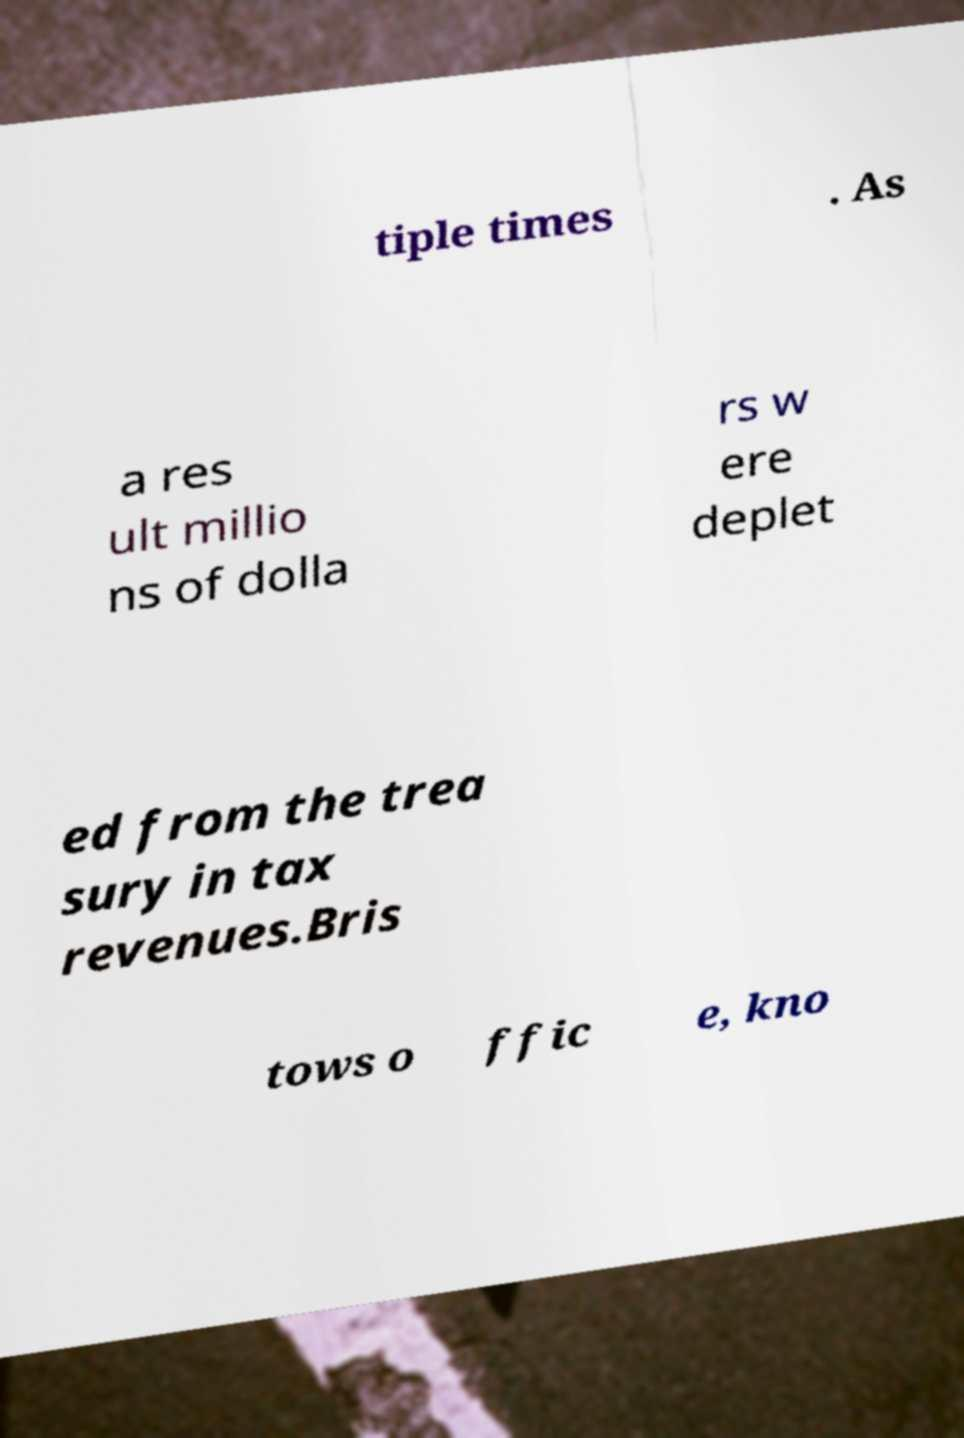There's text embedded in this image that I need extracted. Can you transcribe it verbatim? tiple times . As a res ult millio ns of dolla rs w ere deplet ed from the trea sury in tax revenues.Bris tows o ffic e, kno 